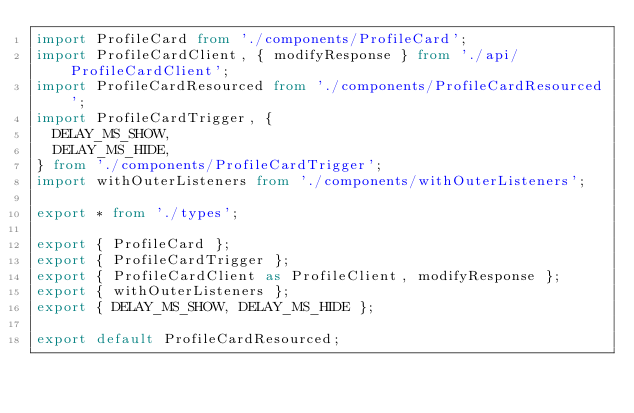Convert code to text. <code><loc_0><loc_0><loc_500><loc_500><_TypeScript_>import ProfileCard from './components/ProfileCard';
import ProfileCardClient, { modifyResponse } from './api/ProfileCardClient';
import ProfileCardResourced from './components/ProfileCardResourced';
import ProfileCardTrigger, {
  DELAY_MS_SHOW,
  DELAY_MS_HIDE,
} from './components/ProfileCardTrigger';
import withOuterListeners from './components/withOuterListeners';

export * from './types';

export { ProfileCard };
export { ProfileCardTrigger };
export { ProfileCardClient as ProfileClient, modifyResponse };
export { withOuterListeners };
export { DELAY_MS_SHOW, DELAY_MS_HIDE };

export default ProfileCardResourced;
</code> 